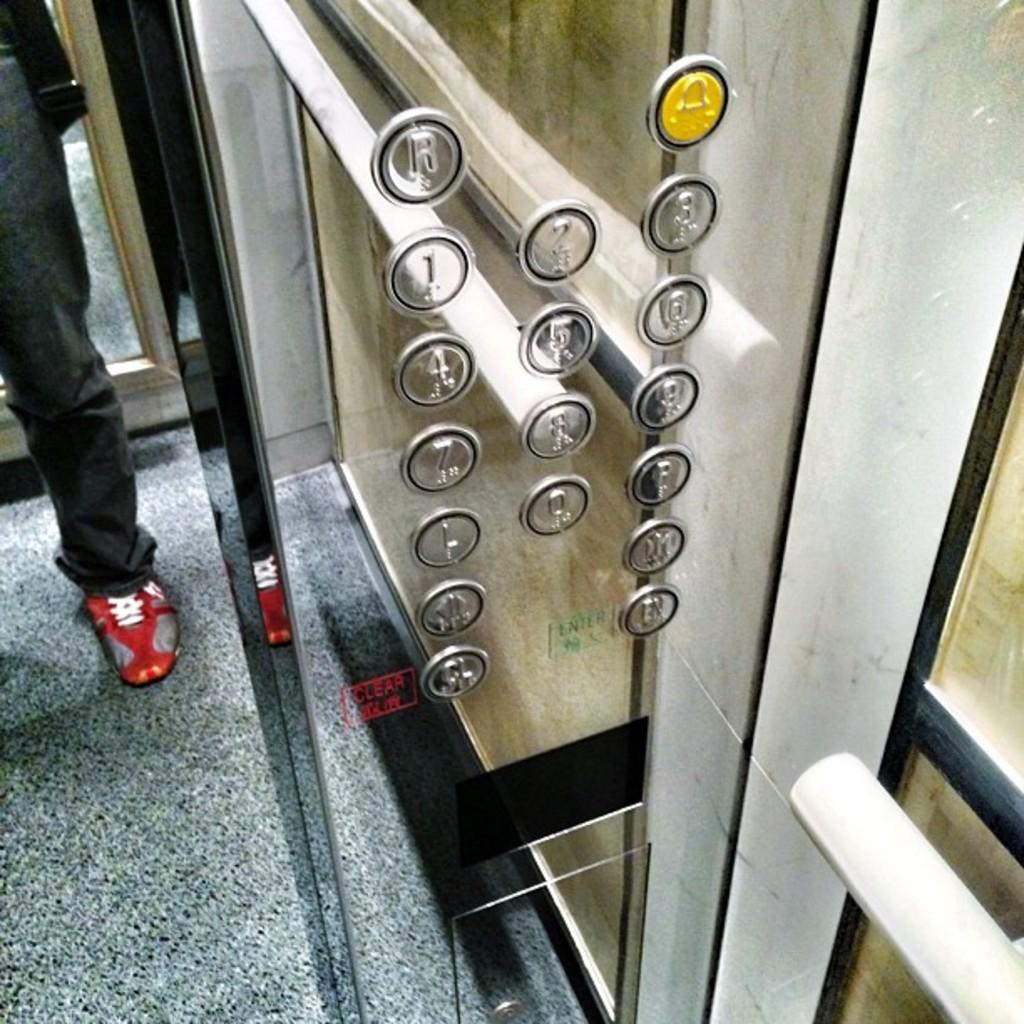What is the person in the image doing? There is a person standing in the elevator. What feature of the elevator is visible in the image? There are buttons on the elevator. What type of rose is the person holding in the image? There is no rose present in the image; the person is standing in an elevator with visible buttons. 